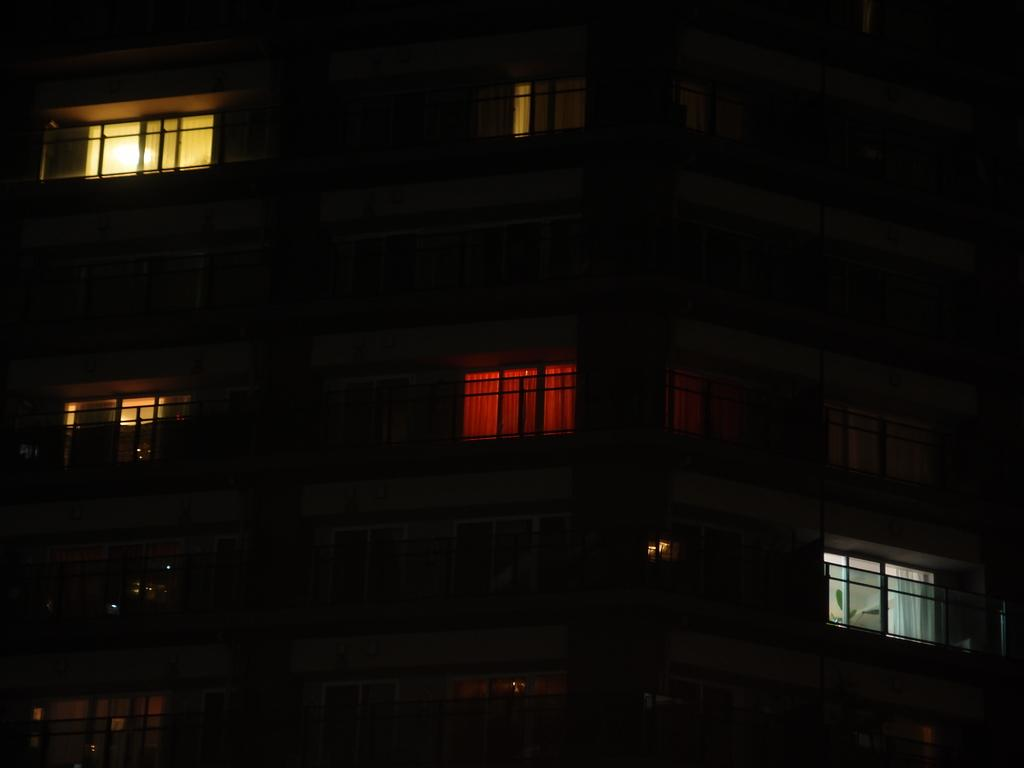What is the main subject of the image? The main subject of the image is a building. Can you describe the building in the image? The building has windows. When was the image taken? The image was taken during night time. What type of friction can be seen between the straw and the hair in the image? There is no straw or hair present in the image; it features a building with windows during night time. 